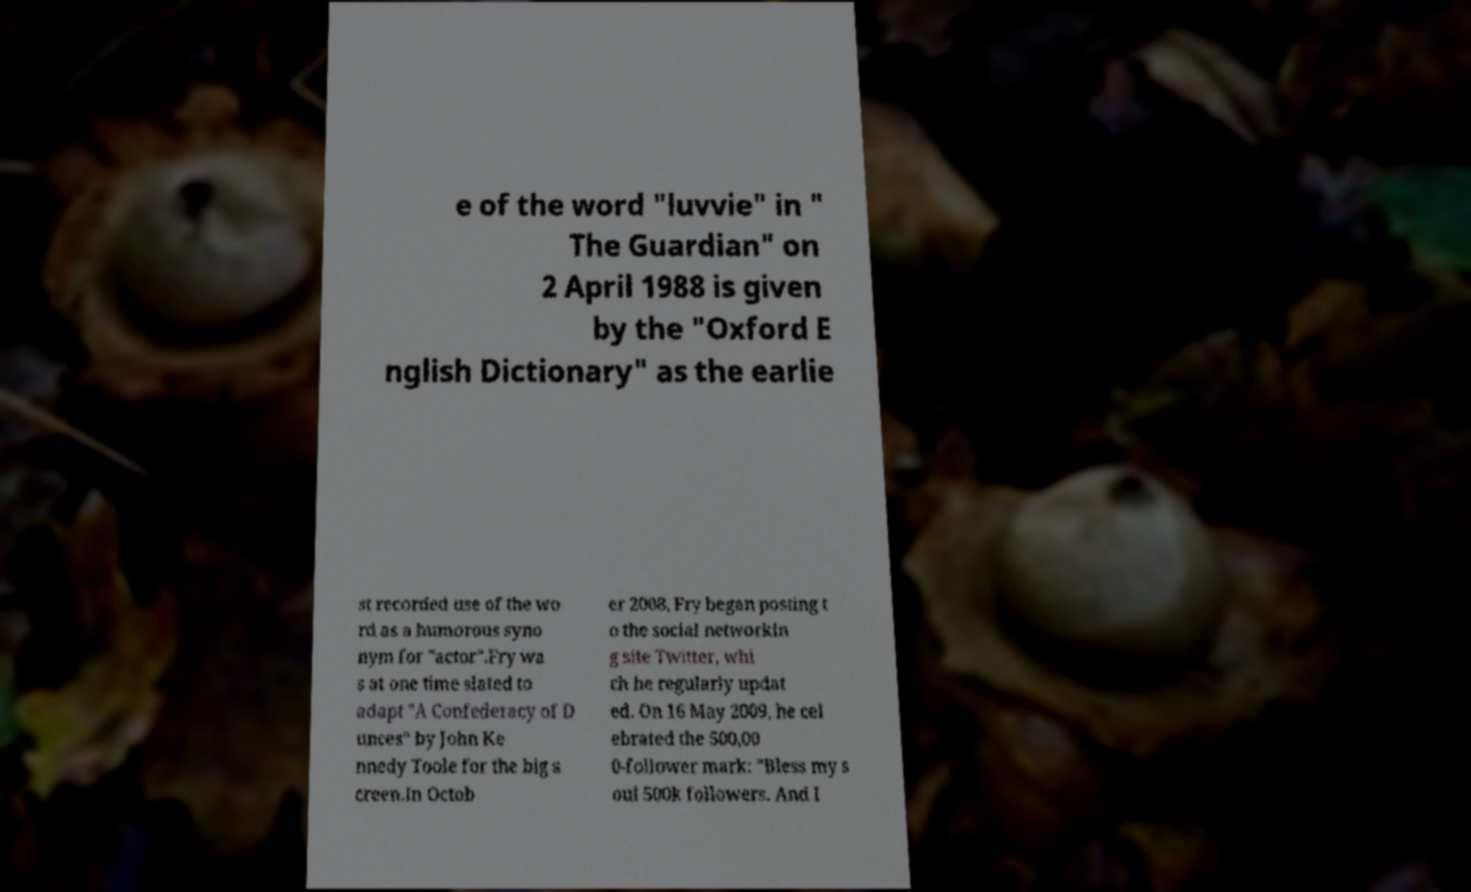For documentation purposes, I need the text within this image transcribed. Could you provide that? e of the word "luvvie" in " The Guardian" on 2 April 1988 is given by the "Oxford E nglish Dictionary" as the earlie st recorded use of the wo rd as a humorous syno nym for "actor".Fry wa s at one time slated to adapt "A Confederacy of D unces" by John Ke nnedy Toole for the big s creen.In Octob er 2008, Fry began posting t o the social networkin g site Twitter, whi ch he regularly updat ed. On 16 May 2009, he cel ebrated the 500,00 0-follower mark: "Bless my s oul 500k followers. And I 